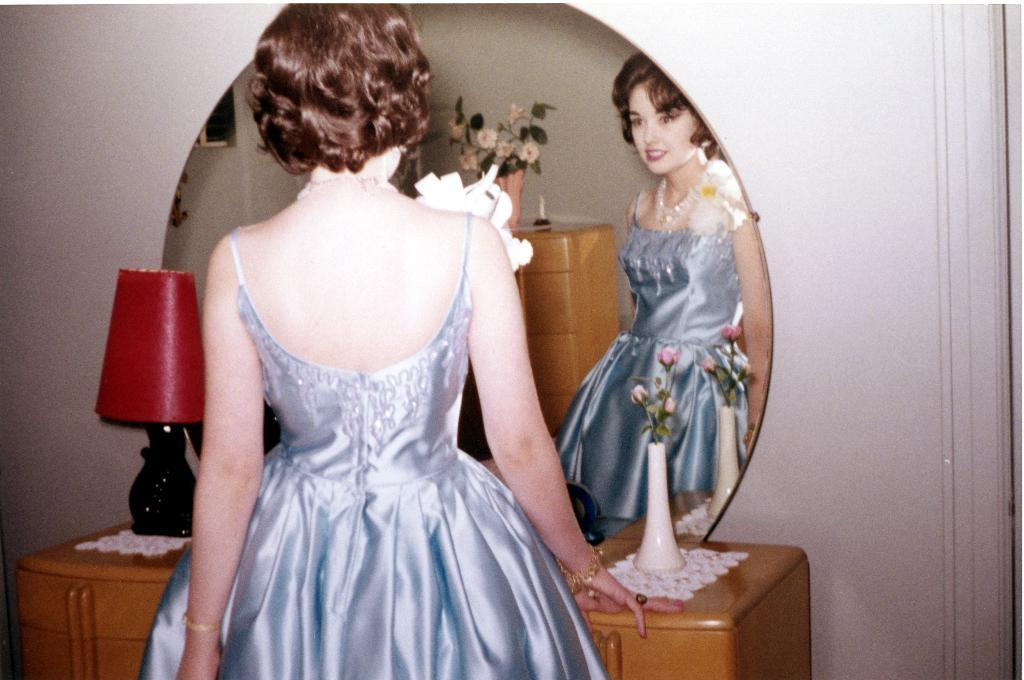Who is the main subject in the image? There is a girl in the image. What is in front of the girl? There is a dressing table in front of the girl. What is on the dressing table? There is a mirror on the dressing table. Can you see the girl's reflection in the mirror? Yes, the girl is reflected in the mirror. What can be seen in the background of the image? There is a wall in the background of the image. What song is the girl singing in the image? There is no indication in the image that the girl is singing, so it cannot be determined from the picture. 